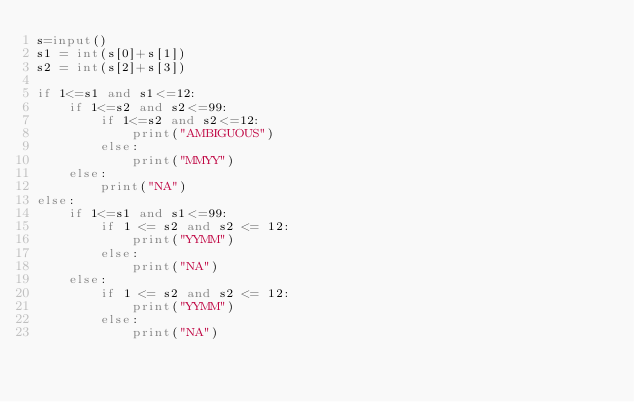<code> <loc_0><loc_0><loc_500><loc_500><_Python_>s=input()
s1 = int(s[0]+s[1])
s2 = int(s[2]+s[3])

if 1<=s1 and s1<=12:
    if 1<=s2 and s2<=99:
        if 1<=s2 and s2<=12:
            print("AMBIGUOUS")
        else:
            print("MMYY")
    else:
        print("NA")
else:
    if 1<=s1 and s1<=99:
        if 1 <= s2 and s2 <= 12:
            print("YYMM")
        else:
            print("NA")
    else:
        if 1 <= s2 and s2 <= 12:
            print("YYMM")
        else:
            print("NA")
</code> 